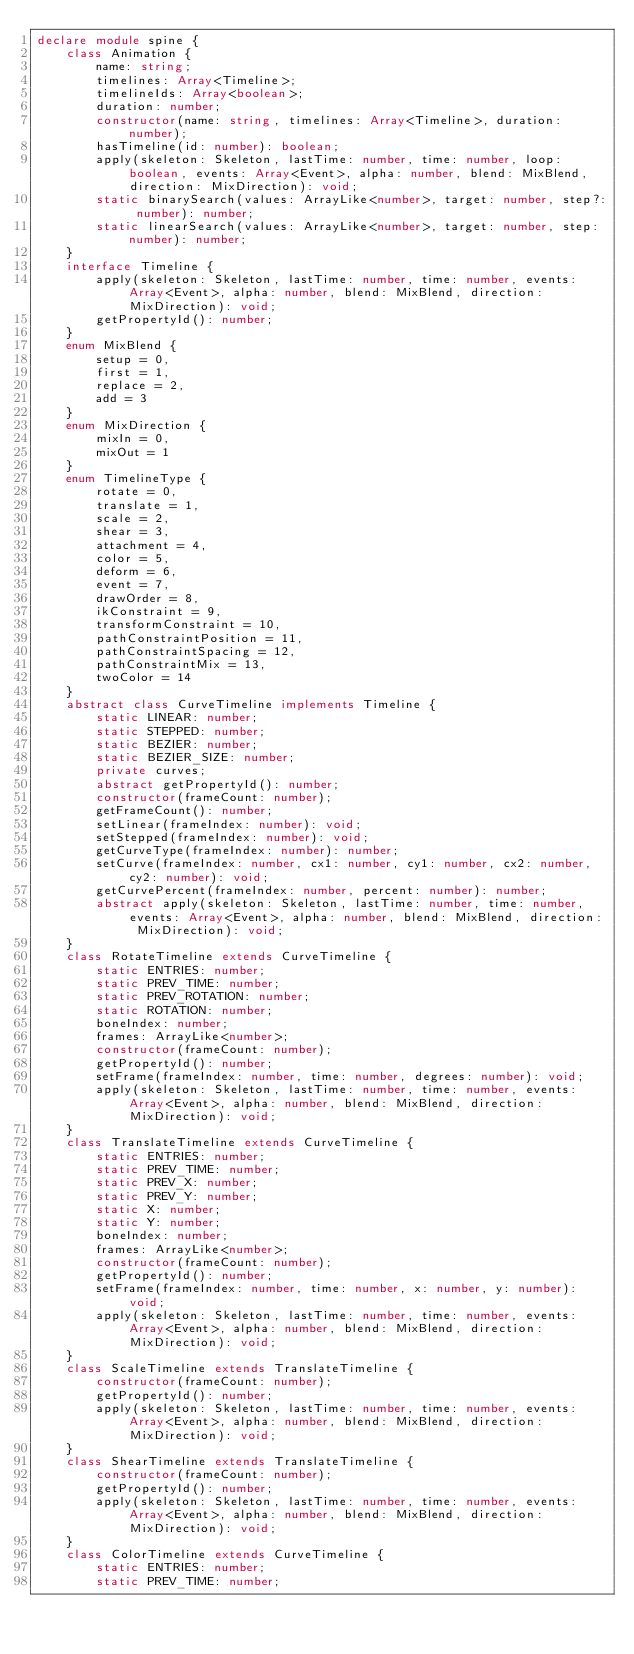Convert code to text. <code><loc_0><loc_0><loc_500><loc_500><_TypeScript_>declare module spine {
    class Animation {
        name: string;
        timelines: Array<Timeline>;
        timelineIds: Array<boolean>;
        duration: number;
        constructor(name: string, timelines: Array<Timeline>, duration: number);
        hasTimeline(id: number): boolean;
        apply(skeleton: Skeleton, lastTime: number, time: number, loop: boolean, events: Array<Event>, alpha: number, blend: MixBlend, direction: MixDirection): void;
        static binarySearch(values: ArrayLike<number>, target: number, step?: number): number;
        static linearSearch(values: ArrayLike<number>, target: number, step: number): number;
    }
    interface Timeline {
        apply(skeleton: Skeleton, lastTime: number, time: number, events: Array<Event>, alpha: number, blend: MixBlend, direction: MixDirection): void;
        getPropertyId(): number;
    }
    enum MixBlend {
        setup = 0,
        first = 1,
        replace = 2,
        add = 3
    }
    enum MixDirection {
        mixIn = 0,
        mixOut = 1
    }
    enum TimelineType {
        rotate = 0,
        translate = 1,
        scale = 2,
        shear = 3,
        attachment = 4,
        color = 5,
        deform = 6,
        event = 7,
        drawOrder = 8,
        ikConstraint = 9,
        transformConstraint = 10,
        pathConstraintPosition = 11,
        pathConstraintSpacing = 12,
        pathConstraintMix = 13,
        twoColor = 14
    }
    abstract class CurveTimeline implements Timeline {
        static LINEAR: number;
        static STEPPED: number;
        static BEZIER: number;
        static BEZIER_SIZE: number;
        private curves;
        abstract getPropertyId(): number;
        constructor(frameCount: number);
        getFrameCount(): number;
        setLinear(frameIndex: number): void;
        setStepped(frameIndex: number): void;
        getCurveType(frameIndex: number): number;
        setCurve(frameIndex: number, cx1: number, cy1: number, cx2: number, cy2: number): void;
        getCurvePercent(frameIndex: number, percent: number): number;
        abstract apply(skeleton: Skeleton, lastTime: number, time: number, events: Array<Event>, alpha: number, blend: MixBlend, direction: MixDirection): void;
    }
    class RotateTimeline extends CurveTimeline {
        static ENTRIES: number;
        static PREV_TIME: number;
        static PREV_ROTATION: number;
        static ROTATION: number;
        boneIndex: number;
        frames: ArrayLike<number>;
        constructor(frameCount: number);
        getPropertyId(): number;
        setFrame(frameIndex: number, time: number, degrees: number): void;
        apply(skeleton: Skeleton, lastTime: number, time: number, events: Array<Event>, alpha: number, blend: MixBlend, direction: MixDirection): void;
    }
    class TranslateTimeline extends CurveTimeline {
        static ENTRIES: number;
        static PREV_TIME: number;
        static PREV_X: number;
        static PREV_Y: number;
        static X: number;
        static Y: number;
        boneIndex: number;
        frames: ArrayLike<number>;
        constructor(frameCount: number);
        getPropertyId(): number;
        setFrame(frameIndex: number, time: number, x: number, y: number): void;
        apply(skeleton: Skeleton, lastTime: number, time: number, events: Array<Event>, alpha: number, blend: MixBlend, direction: MixDirection): void;
    }
    class ScaleTimeline extends TranslateTimeline {
        constructor(frameCount: number);
        getPropertyId(): number;
        apply(skeleton: Skeleton, lastTime: number, time: number, events: Array<Event>, alpha: number, blend: MixBlend, direction: MixDirection): void;
    }
    class ShearTimeline extends TranslateTimeline {
        constructor(frameCount: number);
        getPropertyId(): number;
        apply(skeleton: Skeleton, lastTime: number, time: number, events: Array<Event>, alpha: number, blend: MixBlend, direction: MixDirection): void;
    }
    class ColorTimeline extends CurveTimeline {
        static ENTRIES: number;
        static PREV_TIME: number;</code> 